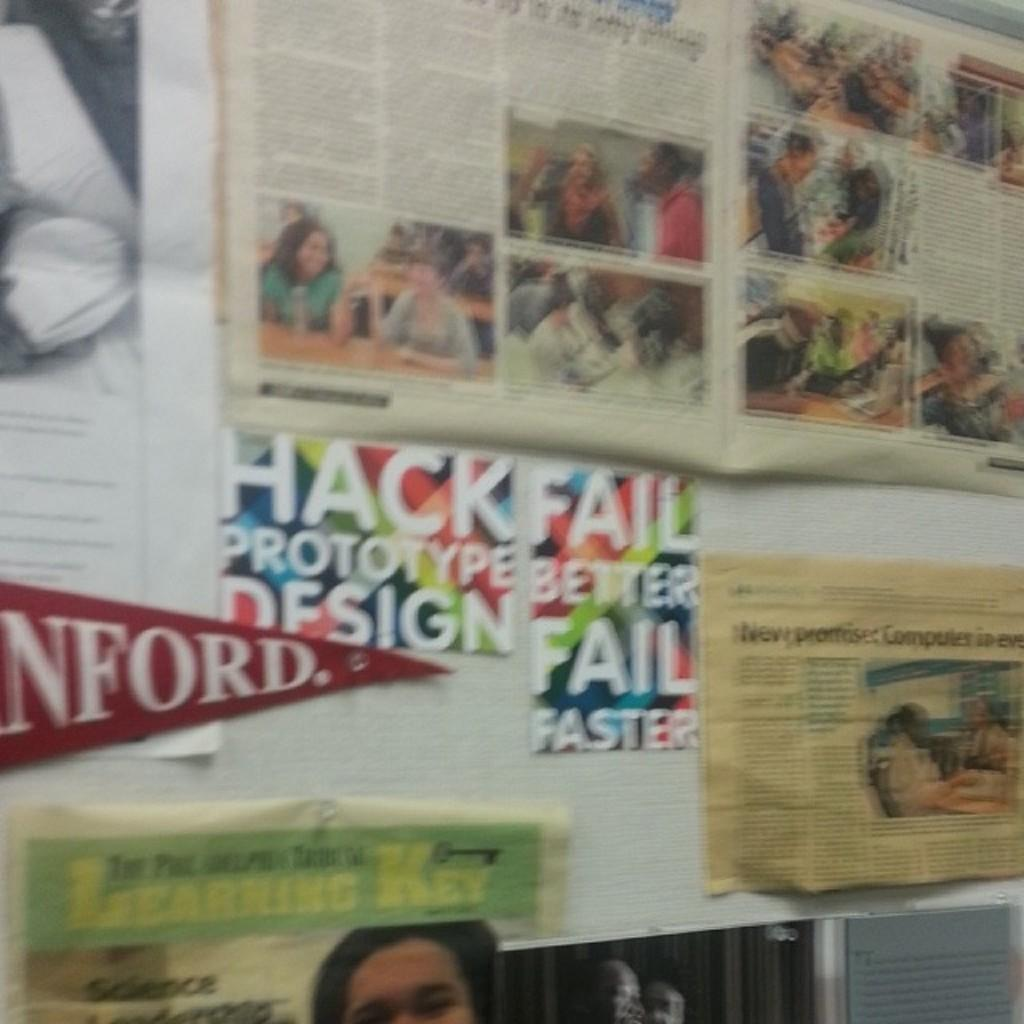<image>
Offer a succinct explanation of the picture presented. A bulletin board with articles, colorful posters and a pennant  pinned on it. 